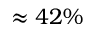Convert formula to latex. <formula><loc_0><loc_0><loc_500><loc_500>\approx 4 2 \%</formula> 